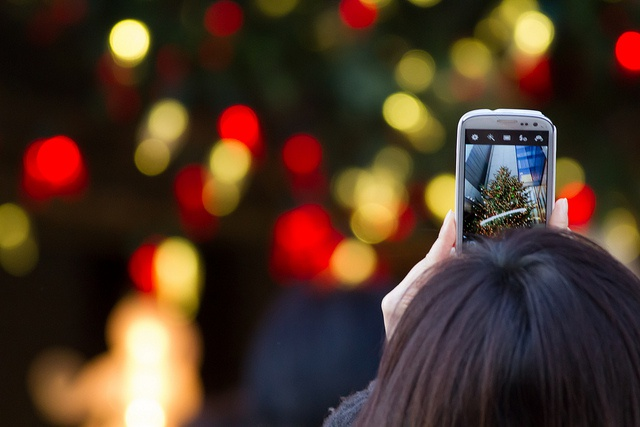Describe the objects in this image and their specific colors. I can see people in black and gray tones and cell phone in black, darkgray, and gray tones in this image. 